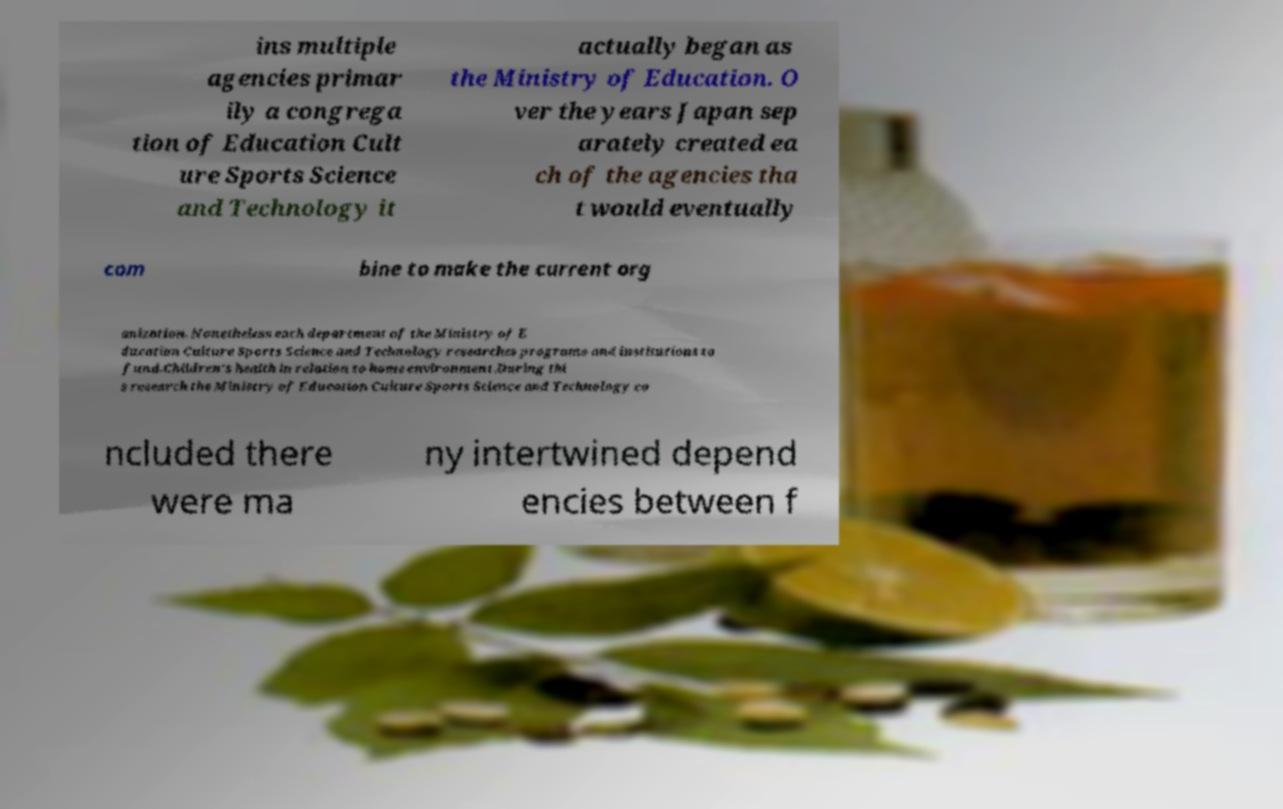What messages or text are displayed in this image? I need them in a readable, typed format. ins multiple agencies primar ily a congrega tion of Education Cult ure Sports Science and Technology it actually began as the Ministry of Education. O ver the years Japan sep arately created ea ch of the agencies tha t would eventually com bine to make the current org anization. Nonetheless each department of the Ministry of E ducation Culture Sports Science and Technology researches programs and institutions to fund.Children's health in relation to home environment.During thi s research the Ministry of Education Culture Sports Science and Technology co ncluded there were ma ny intertwined depend encies between f 